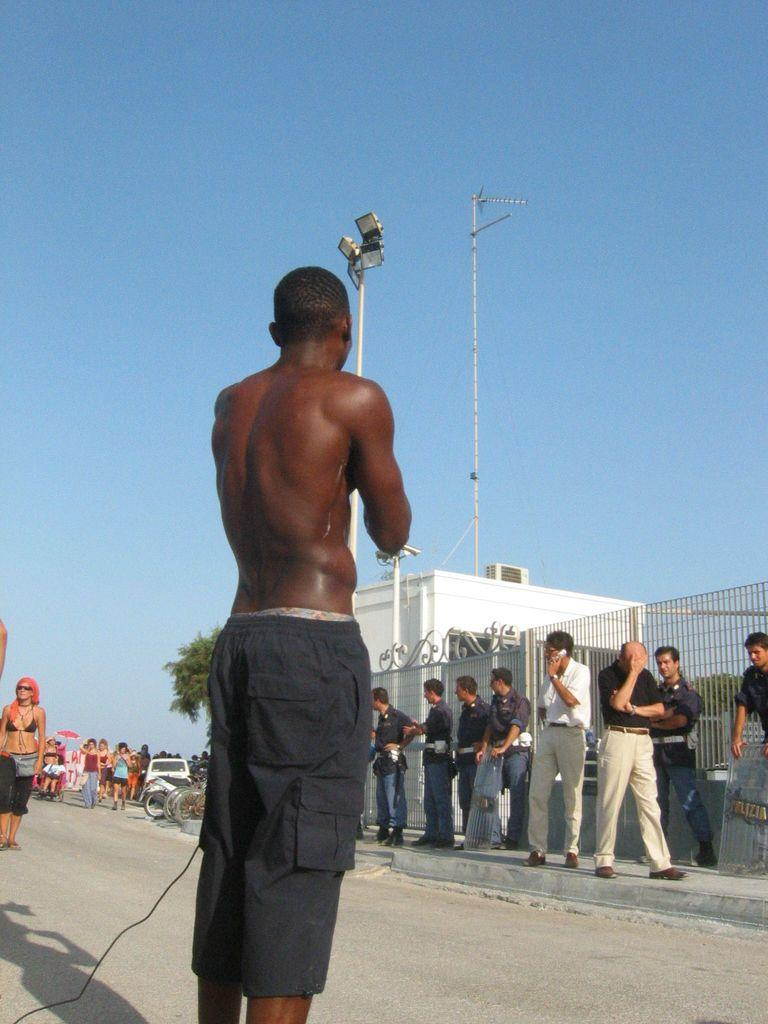Who or what can be seen in the image? There are people in the image. What objects are present in the image related to transportation? There are grilles and vehicles on the road in the image. What type of natural elements can be seen in the image? There are trees in the image. What other structures are present in the image? There are poles and a building in the image. What type of illumination is present in the image? There are lights in the image. What part of the natural environment is visible in the image? The sky is visible at the top of the image. What type of line can be seen connecting the people's minds in the image? There is no line connecting people's minds in the image, nor is there any reference to a line or waste in the provided facts. 